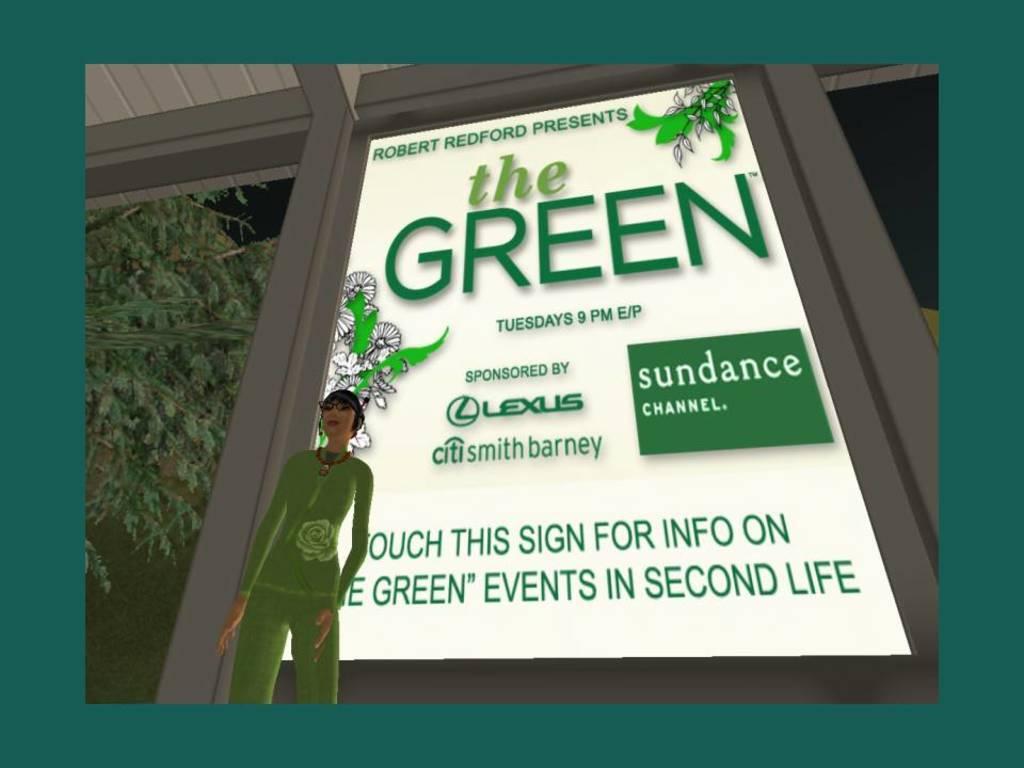How would you summarize this image in a sentence or two? In this picture there is a animated poster of a girl wearing green dress. Behind there is a white color advertising poster. On the left side we can see the tree. 